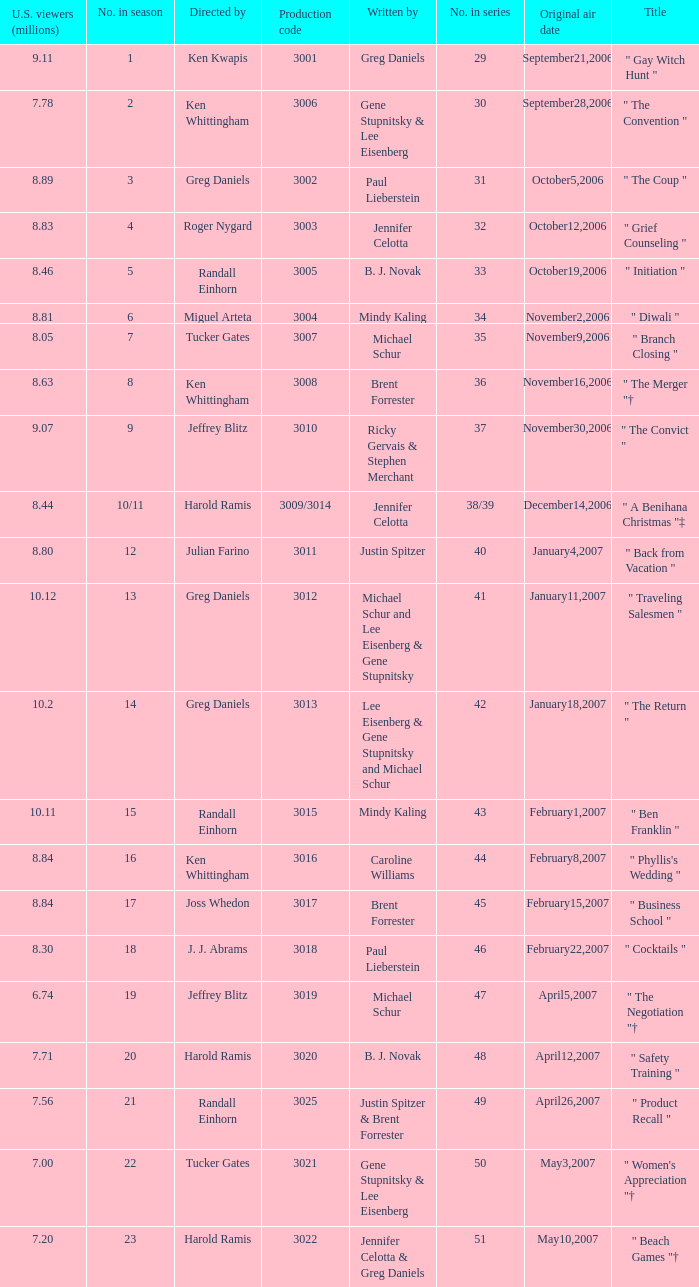Name the number of original air date for when the number in season is 10/11 1.0. 